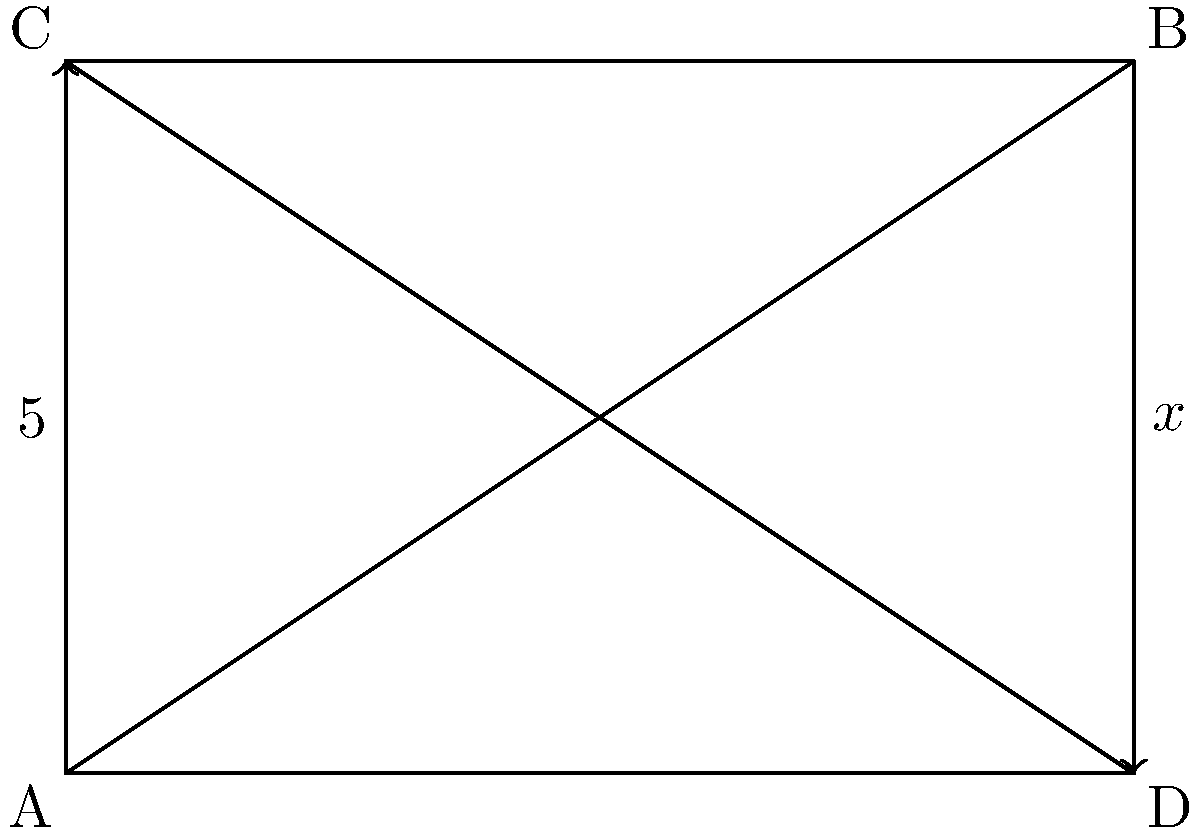In the figure above, lines CD and AB are parallel. If the length of AC is 5 units and the area of the quadrilateral ABCD is 24 square units, what is the length of BD (represented by x in the figure)? Let's approach this step-by-step:

1) First, recall that the area of a trapezoid is given by the formula:
   $$A = \frac{1}{2}(b_1 + b_2)h$$
   where $A$ is the area, $b_1$ and $b_2$ are the lengths of the parallel sides, and $h$ is the height.

2) In this case, we know:
   - The area $A = 24$ square units
   - The height $h = 5$ units (length of AC)
   - One of the parallel sides, CD, has length $x$

3) Let's call the length of AB $y$. We can now set up the equation:
   $$24 = \frac{1}{2}(x + y)5$$

4) Simplify:
   $$24 = \frac{5x + 5y}{2}$$
   $$48 = 5x + 5y$$
   $$9.6 = x + y$$

5) Now, we need to find the relationship between $x$ and $y$. Notice that triangles ACD and ABD are similar (they share an angle at A, and both have a right angle).

6) In similar triangles, the ratio of corresponding sides is constant. So:
   $$\frac{x}{y} = \frac{AC}{AB} = \frac{5}{6}$$

7) This means $y = \frac{6x}{5}$. Substitute this into our equation from step 4:
   $$9.6 = x + \frac{6x}{5}$$

8) Solve for $x$:
   $$9.6 = \frac{5x}{5} + \frac{6x}{5} = \frac{11x}{5}$$
   $$48 = 11x$$
   $$x = \frac{48}{11} \approx 4.36$$

Therefore, the length of BD is $\frac{48}{11}$ units.
Answer: $\frac{48}{11}$ units 